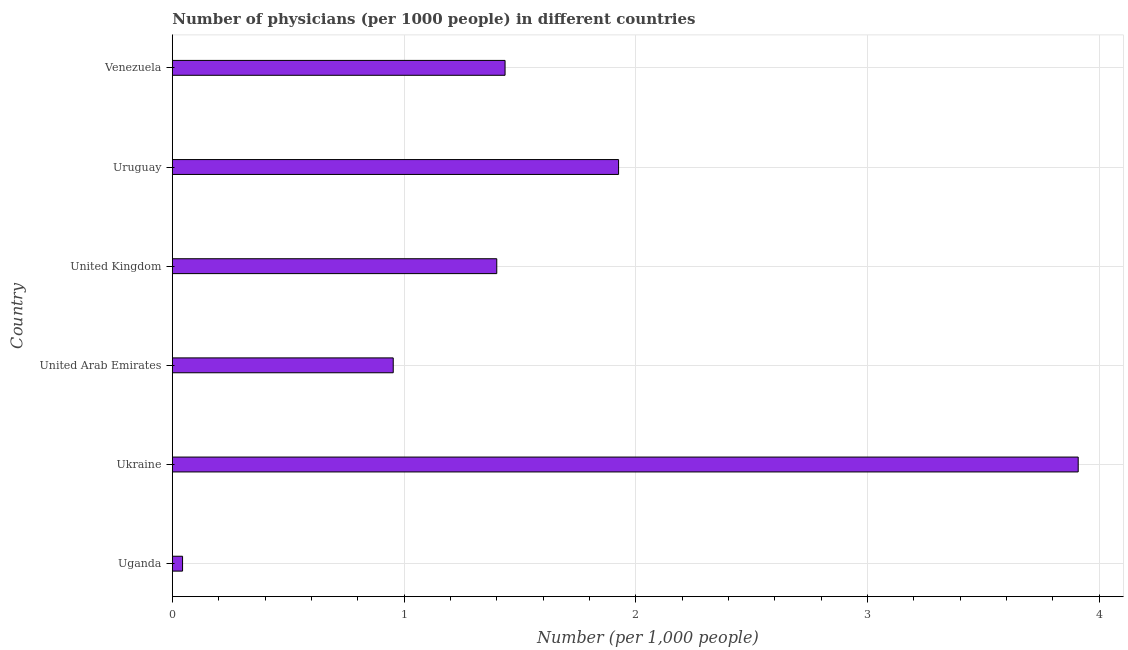What is the title of the graph?
Your answer should be very brief. Number of physicians (per 1000 people) in different countries. What is the label or title of the X-axis?
Your answer should be compact. Number (per 1,0 people). Across all countries, what is the maximum number of physicians?
Ensure brevity in your answer.  3.91. Across all countries, what is the minimum number of physicians?
Your answer should be compact. 0.04. In which country was the number of physicians maximum?
Give a very brief answer. Ukraine. In which country was the number of physicians minimum?
Make the answer very short. Uganda. What is the sum of the number of physicians?
Give a very brief answer. 9.67. What is the difference between the number of physicians in United Arab Emirates and Uruguay?
Offer a terse response. -0.97. What is the average number of physicians per country?
Your answer should be compact. 1.61. What is the median number of physicians?
Keep it short and to the point. 1.42. What is the ratio of the number of physicians in Ukraine to that in Uruguay?
Offer a terse response. 2.03. Is the number of physicians in Uganda less than that in United Kingdom?
Provide a short and direct response. Yes. Is the difference between the number of physicians in Ukraine and United Arab Emirates greater than the difference between any two countries?
Ensure brevity in your answer.  No. What is the difference between the highest and the second highest number of physicians?
Offer a terse response. 1.98. Is the sum of the number of physicians in United Arab Emirates and United Kingdom greater than the maximum number of physicians across all countries?
Keep it short and to the point. No. What is the difference between the highest and the lowest number of physicians?
Your answer should be compact. 3.87. How many bars are there?
Ensure brevity in your answer.  6. Are all the bars in the graph horizontal?
Keep it short and to the point. Yes. Are the values on the major ticks of X-axis written in scientific E-notation?
Ensure brevity in your answer.  No. What is the Number (per 1,000 people) in Uganda?
Give a very brief answer. 0.04. What is the Number (per 1,000 people) of Ukraine?
Offer a very short reply. 3.91. What is the Number (per 1,000 people) of United Arab Emirates?
Ensure brevity in your answer.  0.95. What is the Number (per 1,000 people) in Uruguay?
Your response must be concise. 1.93. What is the Number (per 1,000 people) of Venezuela?
Your answer should be compact. 1.44. What is the difference between the Number (per 1,000 people) in Uganda and Ukraine?
Your response must be concise. -3.87. What is the difference between the Number (per 1,000 people) in Uganda and United Arab Emirates?
Provide a succinct answer. -0.91. What is the difference between the Number (per 1,000 people) in Uganda and United Kingdom?
Your response must be concise. -1.36. What is the difference between the Number (per 1,000 people) in Uganda and Uruguay?
Offer a terse response. -1.88. What is the difference between the Number (per 1,000 people) in Uganda and Venezuela?
Your answer should be compact. -1.39. What is the difference between the Number (per 1,000 people) in Ukraine and United Arab Emirates?
Your answer should be compact. 2.96. What is the difference between the Number (per 1,000 people) in Ukraine and United Kingdom?
Your answer should be compact. 2.51. What is the difference between the Number (per 1,000 people) in Ukraine and Uruguay?
Provide a short and direct response. 1.98. What is the difference between the Number (per 1,000 people) in Ukraine and Venezuela?
Offer a very short reply. 2.47. What is the difference between the Number (per 1,000 people) in United Arab Emirates and United Kingdom?
Your response must be concise. -0.45. What is the difference between the Number (per 1,000 people) in United Arab Emirates and Uruguay?
Your response must be concise. -0.97. What is the difference between the Number (per 1,000 people) in United Arab Emirates and Venezuela?
Provide a succinct answer. -0.48. What is the difference between the Number (per 1,000 people) in United Kingdom and Uruguay?
Your answer should be very brief. -0.53. What is the difference between the Number (per 1,000 people) in United Kingdom and Venezuela?
Give a very brief answer. -0.04. What is the difference between the Number (per 1,000 people) in Uruguay and Venezuela?
Offer a terse response. 0.49. What is the ratio of the Number (per 1,000 people) in Uganda to that in Ukraine?
Offer a very short reply. 0.01. What is the ratio of the Number (per 1,000 people) in Uganda to that in United Arab Emirates?
Make the answer very short. 0.05. What is the ratio of the Number (per 1,000 people) in Uganda to that in United Kingdom?
Ensure brevity in your answer.  0.03. What is the ratio of the Number (per 1,000 people) in Uganda to that in Uruguay?
Provide a short and direct response. 0.02. What is the ratio of the Number (per 1,000 people) in Uganda to that in Venezuela?
Give a very brief answer. 0.03. What is the ratio of the Number (per 1,000 people) in Ukraine to that in United Arab Emirates?
Your answer should be very brief. 4.1. What is the ratio of the Number (per 1,000 people) in Ukraine to that in United Kingdom?
Ensure brevity in your answer.  2.79. What is the ratio of the Number (per 1,000 people) in Ukraine to that in Uruguay?
Your response must be concise. 2.03. What is the ratio of the Number (per 1,000 people) in Ukraine to that in Venezuela?
Offer a very short reply. 2.72. What is the ratio of the Number (per 1,000 people) in United Arab Emirates to that in United Kingdom?
Keep it short and to the point. 0.68. What is the ratio of the Number (per 1,000 people) in United Arab Emirates to that in Uruguay?
Provide a succinct answer. 0.49. What is the ratio of the Number (per 1,000 people) in United Arab Emirates to that in Venezuela?
Keep it short and to the point. 0.66. What is the ratio of the Number (per 1,000 people) in United Kingdom to that in Uruguay?
Ensure brevity in your answer.  0.73. What is the ratio of the Number (per 1,000 people) in United Kingdom to that in Venezuela?
Ensure brevity in your answer.  0.97. What is the ratio of the Number (per 1,000 people) in Uruguay to that in Venezuela?
Offer a terse response. 1.34. 